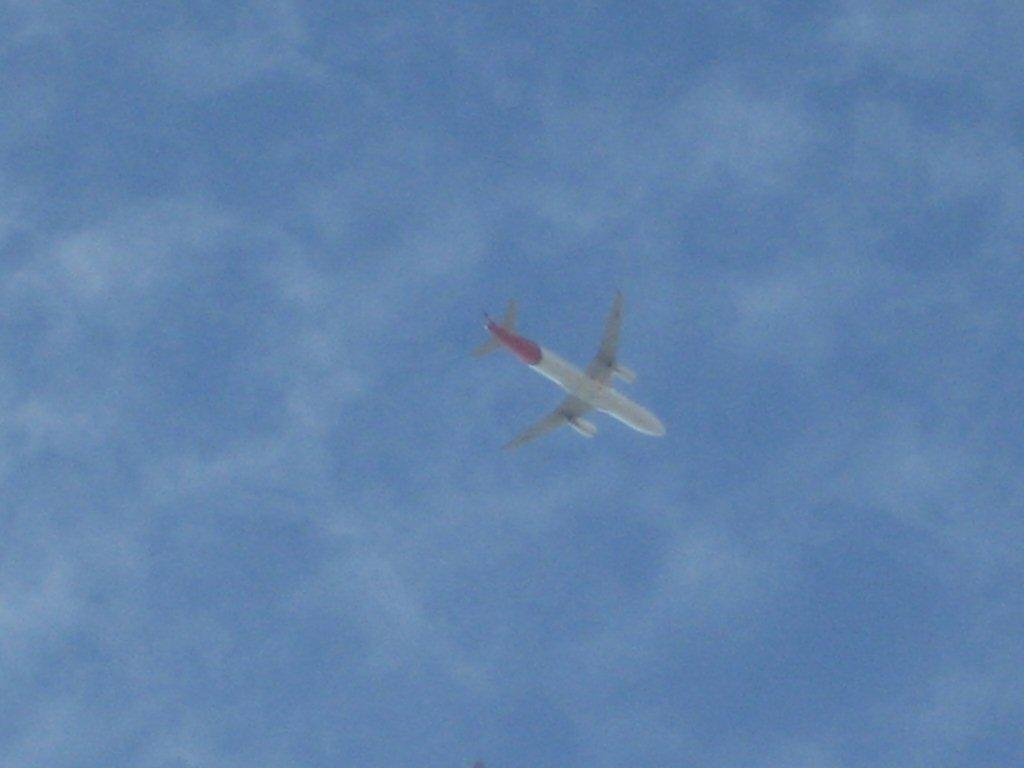What color is the airplane in the image? The airplane is white in the image. Where is the airplane located? The airplane is in the sky in the image. What can be seen in the background of the image? There are clouds in the background of the image. What is the color of the sky in the image? The sky is blue in the image. What type of pipe is visible on the side of the airplane in the image? There is no pipe visible on the side of the airplane in the image. What industry is represented by the airplane in the image? The image does not represent any specific industry; it simply shows an airplane in the sky. 